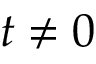<formula> <loc_0><loc_0><loc_500><loc_500>t \ne 0</formula> 